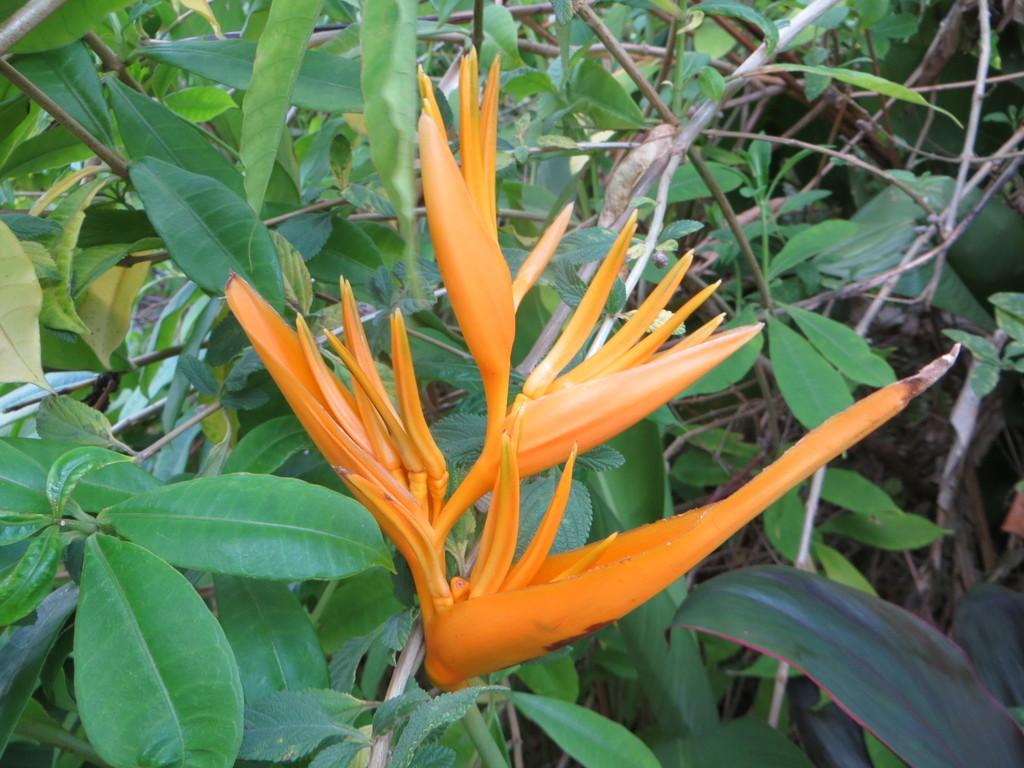What color are the flowers in the image? The flowers in the image are orange. What type of plants are the flowers on? The flowers are on plants. What type of polish is being applied to the army vehicles in the image? There is no mention of an army or vehicles in the image; it only features orange color flowers on plants. 